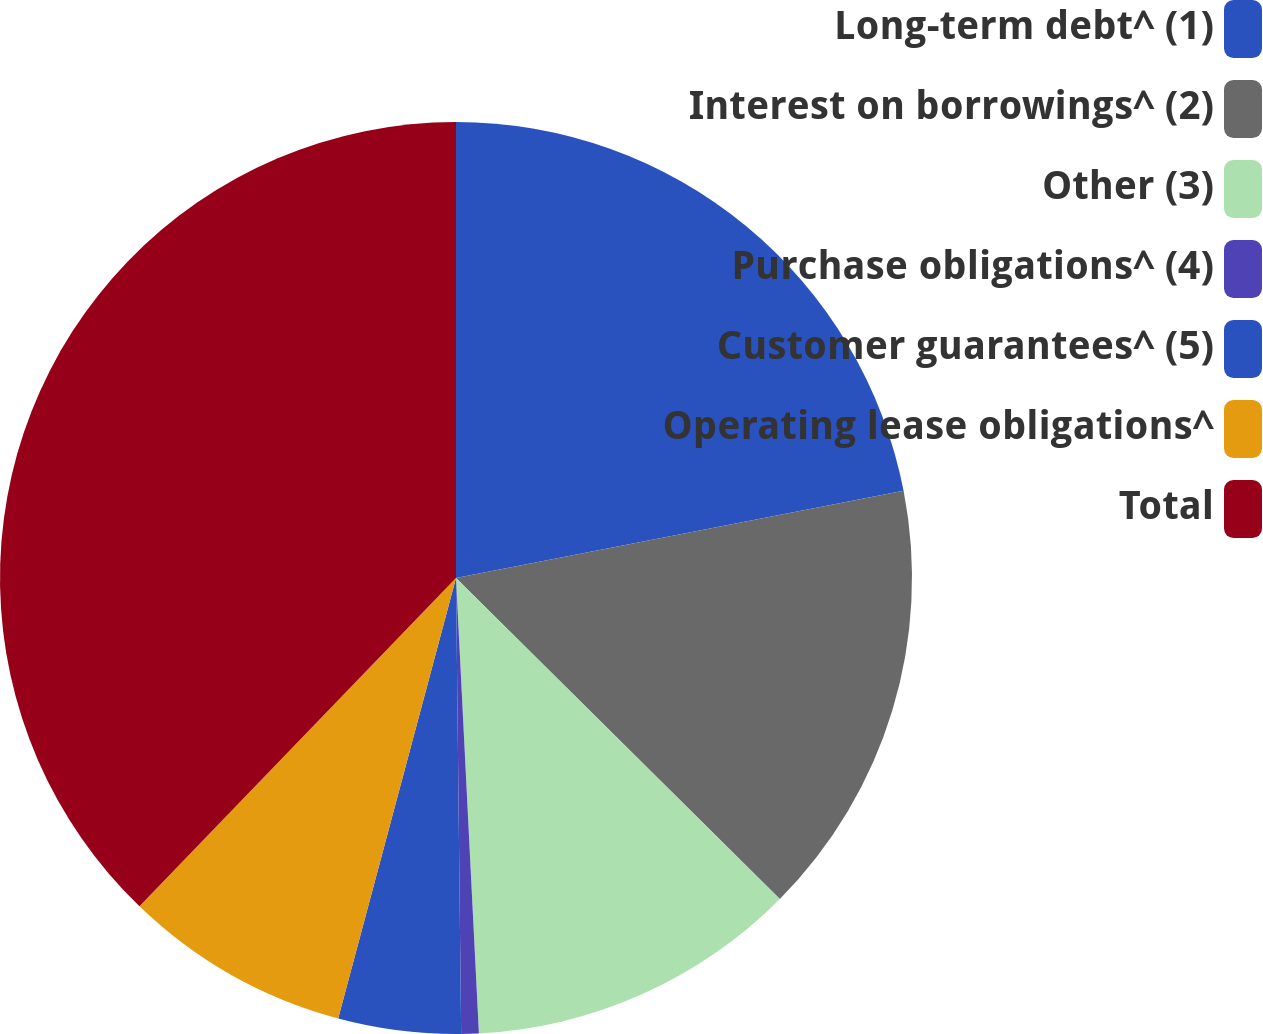Convert chart to OTSL. <chart><loc_0><loc_0><loc_500><loc_500><pie_chart><fcel>Long-term debt^ (1)<fcel>Interest on borrowings^ (2)<fcel>Other (3)<fcel>Purchase obligations^ (4)<fcel>Customer guarantees^ (5)<fcel>Operating lease obligations^<fcel>Total<nl><fcel>21.94%<fcel>15.49%<fcel>11.77%<fcel>0.62%<fcel>4.34%<fcel>8.05%<fcel>37.79%<nl></chart> 